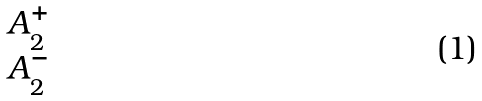Convert formula to latex. <formula><loc_0><loc_0><loc_500><loc_500>\begin{matrix} A _ { 2 } ^ { + } \\ A _ { 2 } ^ { - } \end{matrix}</formula> 